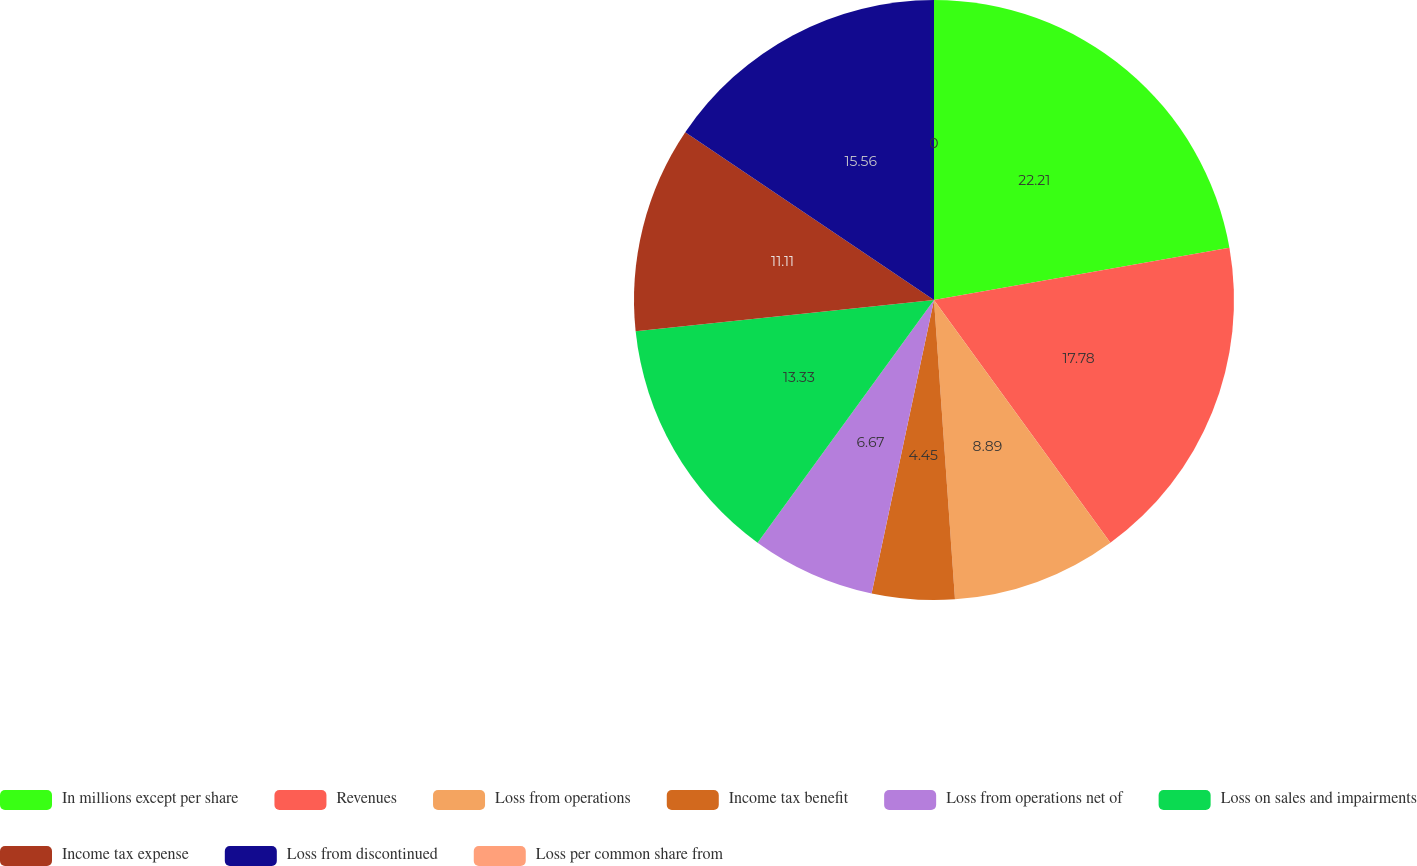<chart> <loc_0><loc_0><loc_500><loc_500><pie_chart><fcel>In millions except per share<fcel>Revenues<fcel>Loss from operations<fcel>Income tax benefit<fcel>Loss from operations net of<fcel>Loss on sales and impairments<fcel>Income tax expense<fcel>Loss from discontinued<fcel>Loss per common share from<nl><fcel>22.22%<fcel>17.78%<fcel>8.89%<fcel>4.45%<fcel>6.67%<fcel>13.33%<fcel>11.11%<fcel>15.56%<fcel>0.0%<nl></chart> 